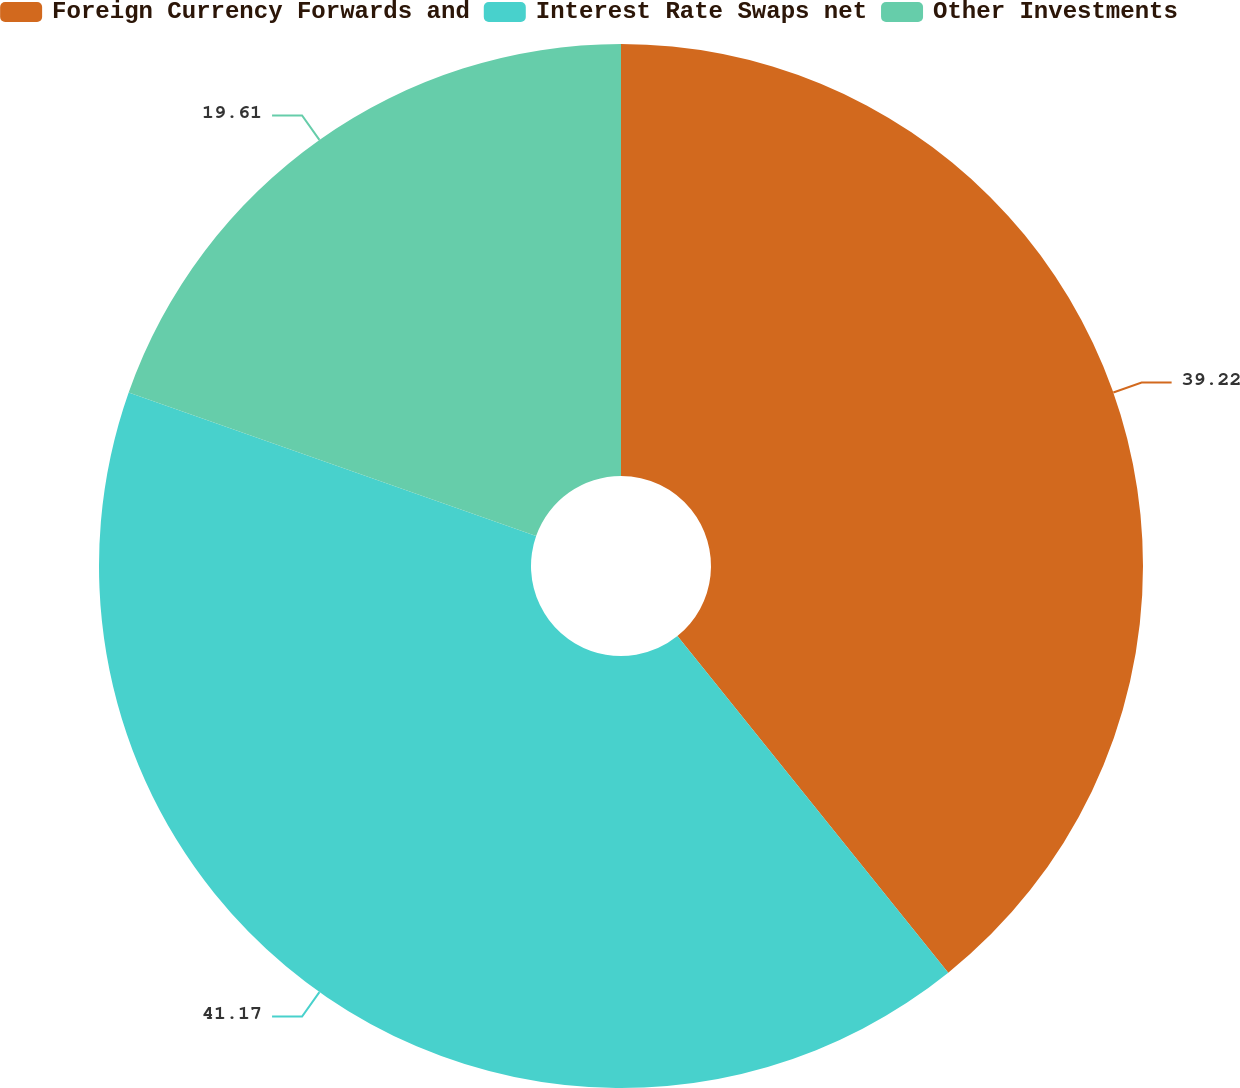<chart> <loc_0><loc_0><loc_500><loc_500><pie_chart><fcel>Foreign Currency Forwards and<fcel>Interest Rate Swaps net<fcel>Other Investments<nl><fcel>39.22%<fcel>41.18%<fcel>19.61%<nl></chart> 